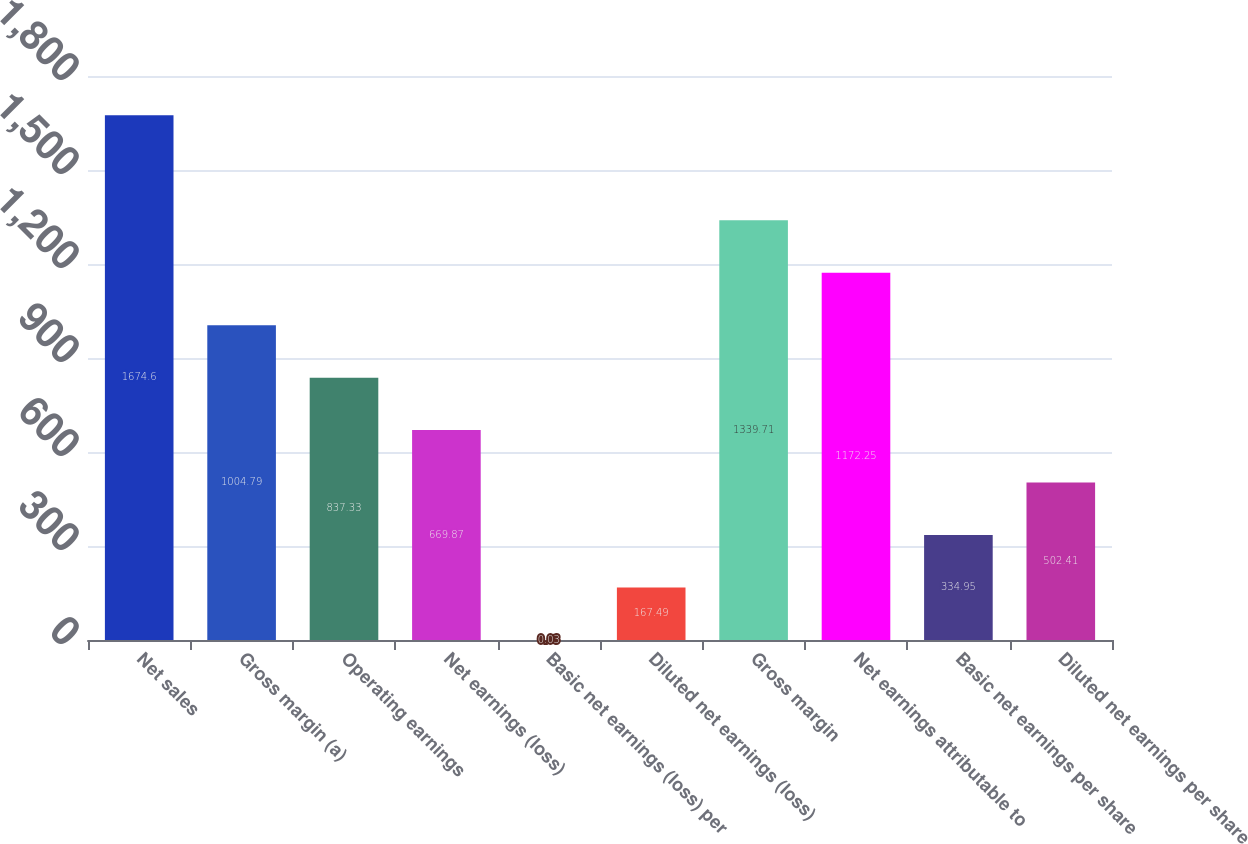<chart> <loc_0><loc_0><loc_500><loc_500><bar_chart><fcel>Net sales<fcel>Gross margin (a)<fcel>Operating earnings<fcel>Net earnings (loss)<fcel>Basic net earnings (loss) per<fcel>Diluted net earnings (loss)<fcel>Gross margin<fcel>Net earnings attributable to<fcel>Basic net earnings per share<fcel>Diluted net earnings per share<nl><fcel>1674.6<fcel>1004.79<fcel>837.33<fcel>669.87<fcel>0.03<fcel>167.49<fcel>1339.71<fcel>1172.25<fcel>334.95<fcel>502.41<nl></chart> 